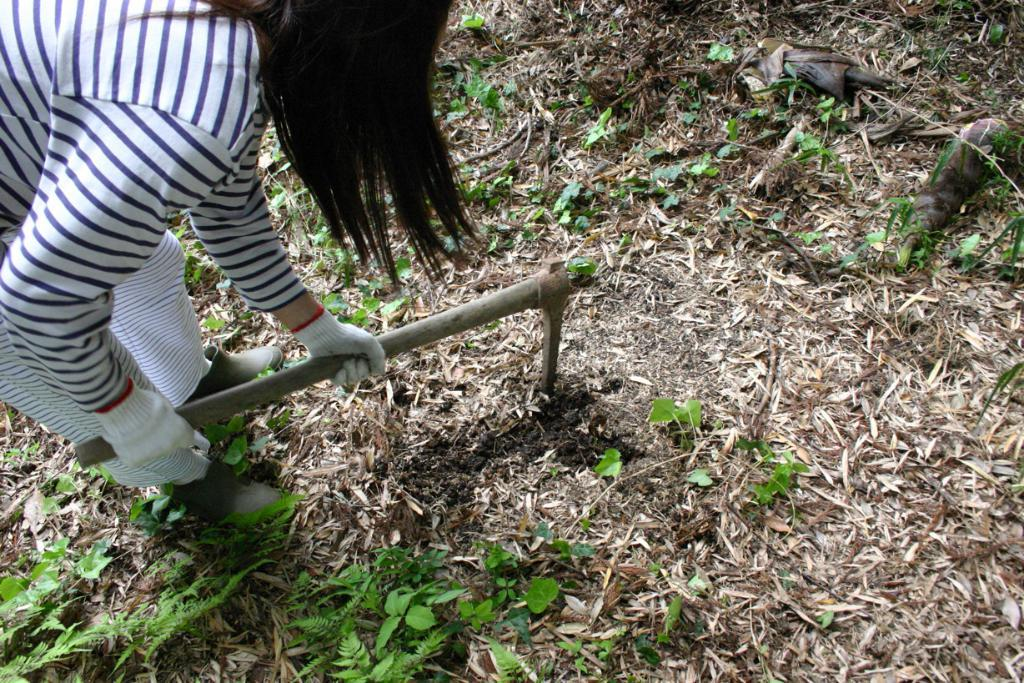What is the person in the image doing? The person is standing on the ground and holding an axe in their hands. What can be seen in the background of the image? There are plants in the background of the image. What is present on the ground in the image? Shredded leaves are present on the ground in the image. What is the purpose of the knowledge in the image? There is no knowledge present in the image; it features a person holding an axe and plants in the background. 